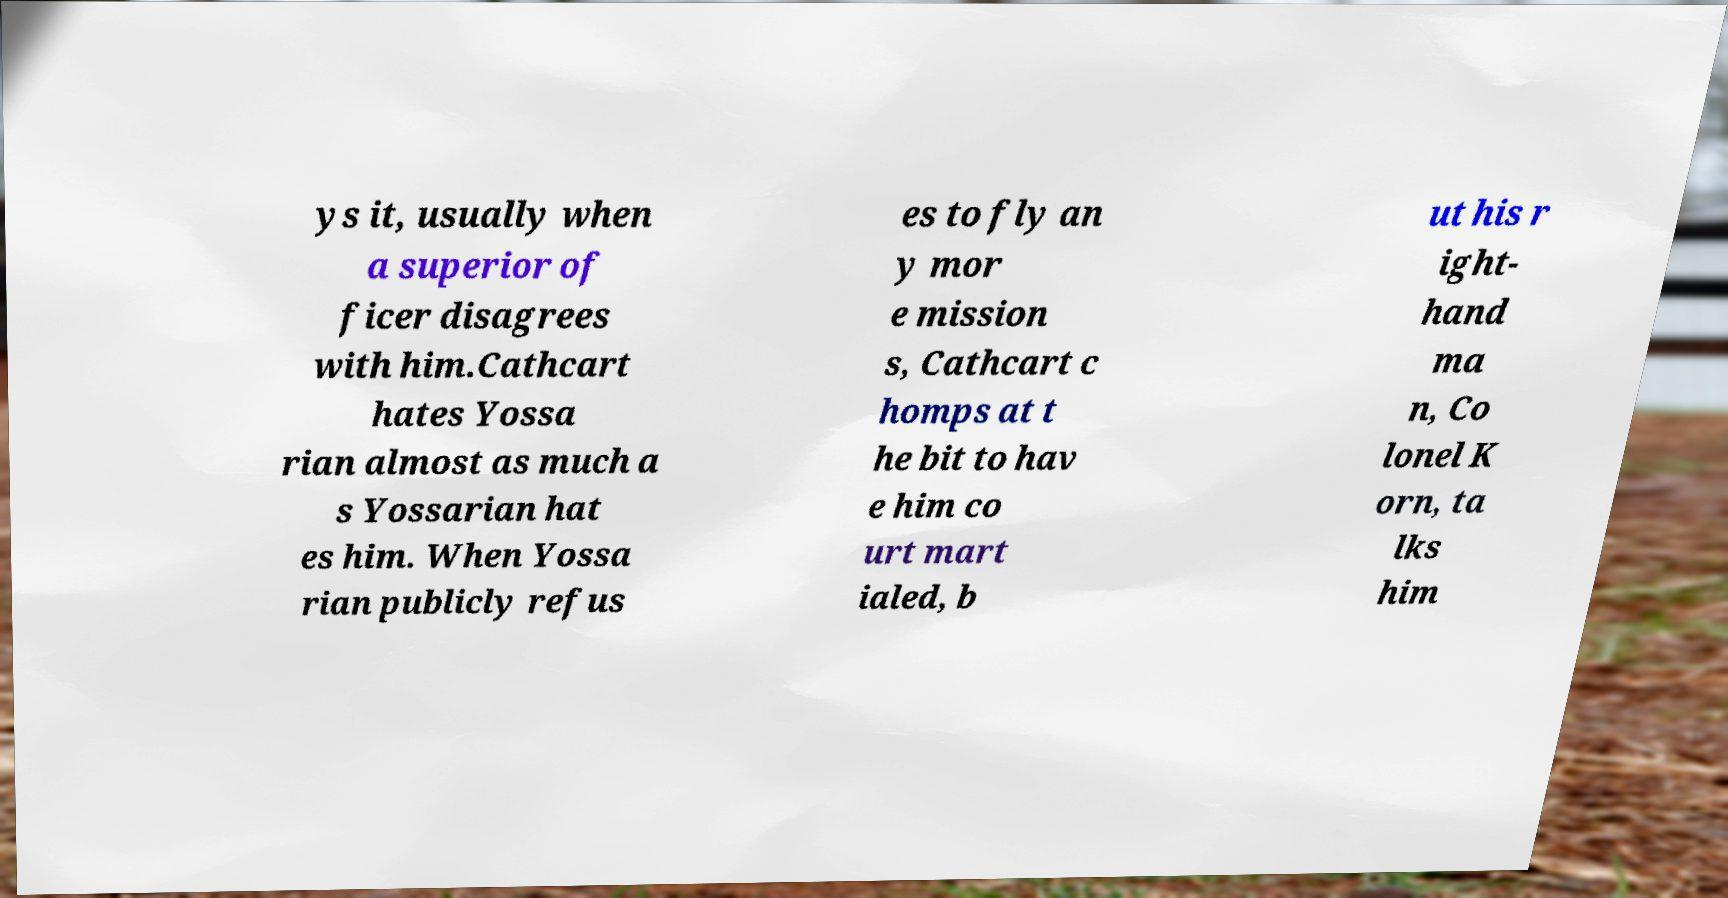I need the written content from this picture converted into text. Can you do that? ys it, usually when a superior of ficer disagrees with him.Cathcart hates Yossa rian almost as much a s Yossarian hat es him. When Yossa rian publicly refus es to fly an y mor e mission s, Cathcart c homps at t he bit to hav e him co urt mart ialed, b ut his r ight- hand ma n, Co lonel K orn, ta lks him 